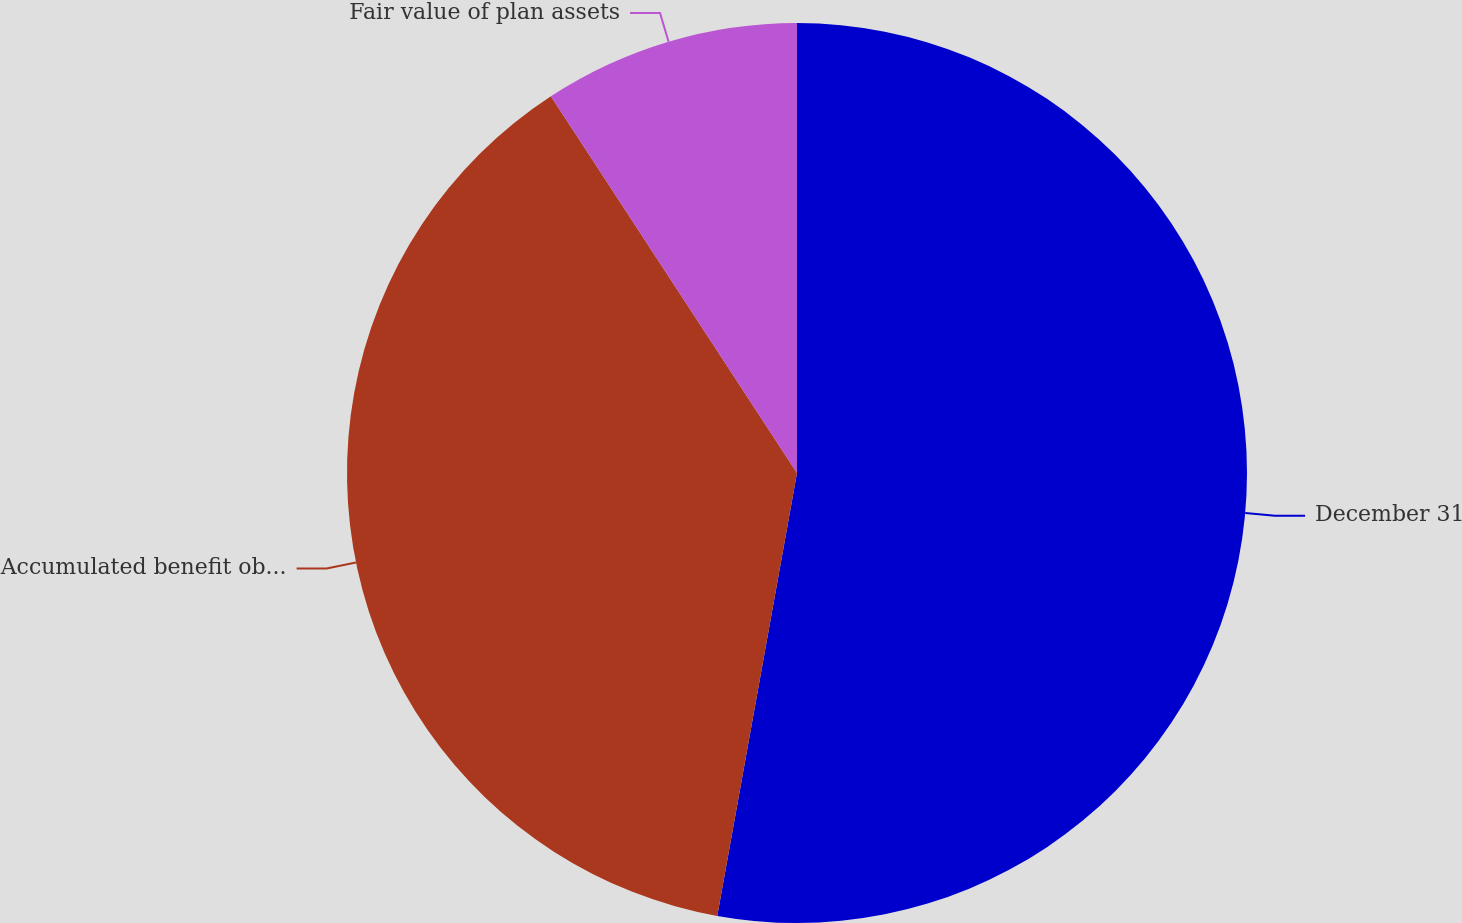Convert chart to OTSL. <chart><loc_0><loc_0><loc_500><loc_500><pie_chart><fcel>December 31<fcel>Accumulated benefit obligation<fcel>Fair value of plan assets<nl><fcel>52.83%<fcel>37.95%<fcel>9.21%<nl></chart> 